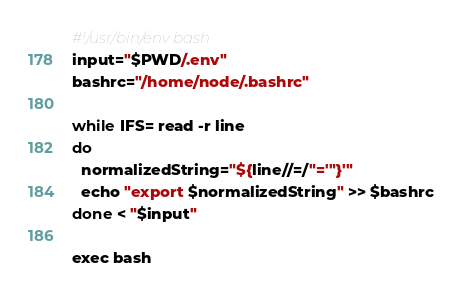<code> <loc_0><loc_0><loc_500><loc_500><_Bash_>#!/usr/bin/env bash
input="$PWD/.env"
bashrc="/home/node/.bashrc"

while IFS= read -r line
do
  normalizedString="${line//=/"='"}'"
  echo "export $normalizedString" >> $bashrc
done < "$input"

exec bash</code> 